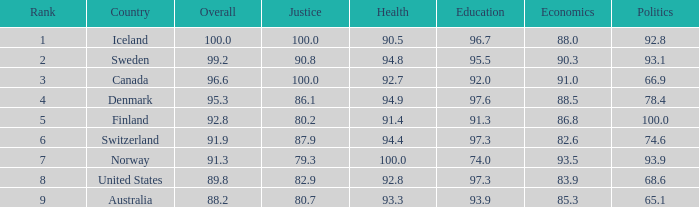What is the financial rating when the education score is 9 91.0. 